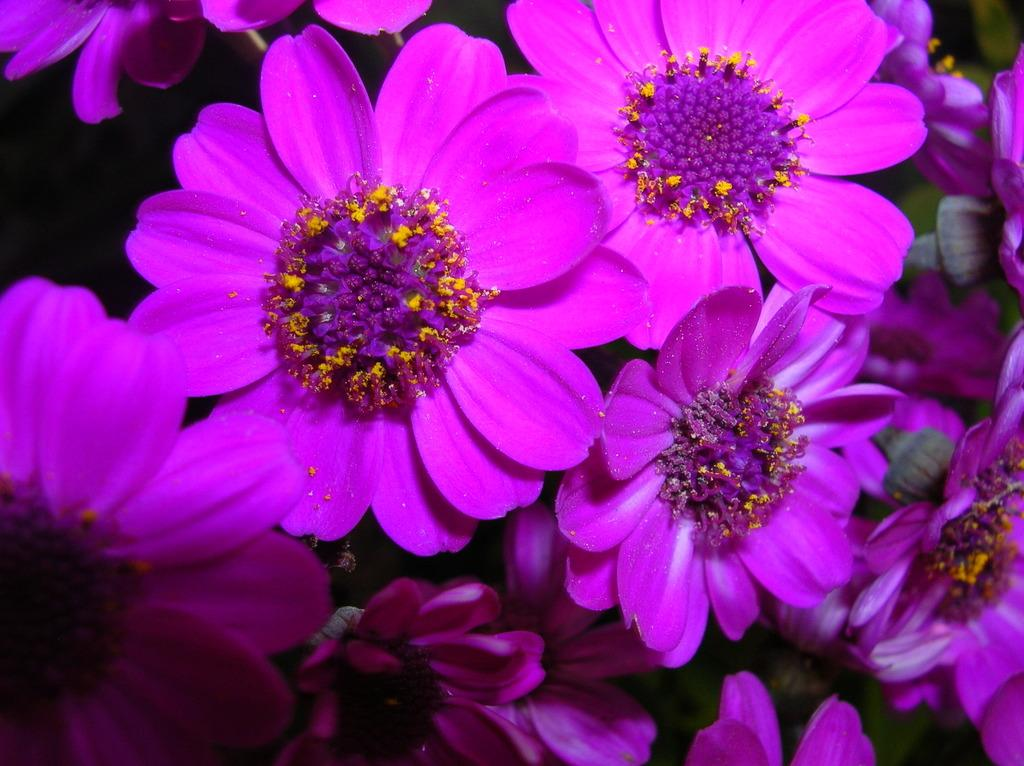What type of living organisms can be seen in the image? There are flowers in the image. How many pies are being shared between the girl and the boy in the image? There is no girl, boy, or pies present in the image; it only features flowers. 